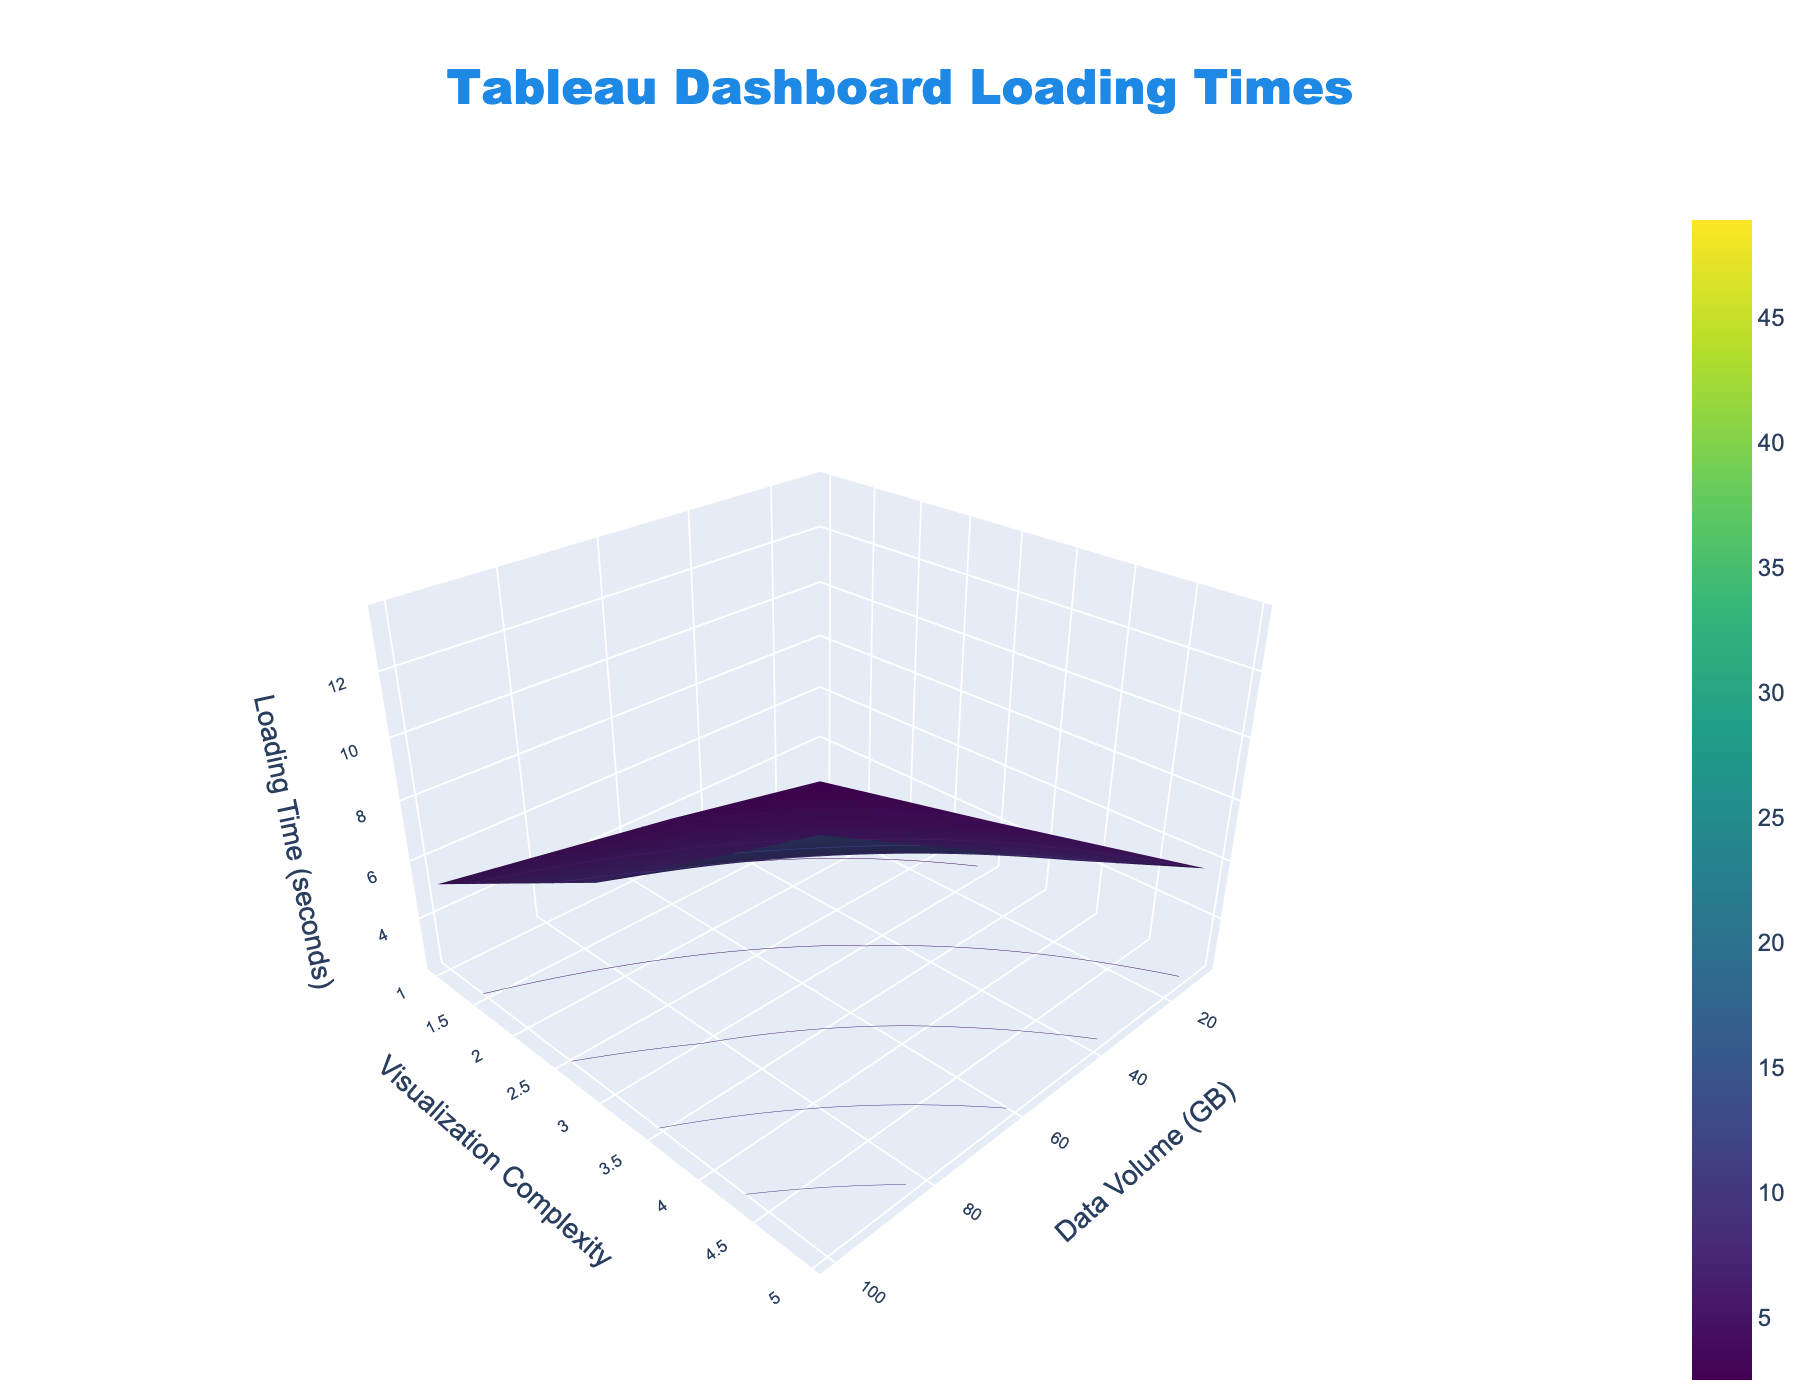What is the title of the 3D surface plot? The title of the plot is prominent at the top and reads "Tableau Dashboard Loading Times."
Answer: Tableau Dashboard Loading Times What are the labels for the x-axis, y-axis, and z-axis? The x-axis is labeled "Data Volume (GB)," the y-axis is labeled "Visualization Complexity," and the z-axis is labeled "Loading Time (seconds)," as indicated in the respective axis titles.
Answer: Data Volume (GB), Visualization Complexity, Loading Time (seconds) How does loading time change as the data volume increases from 10 GB to 1000 GB for a visualization complexity of 1? Observing the plot, as the data volume increases from 10 GB to 1000 GB, the loading time increases from 2.5 seconds to 18.7 seconds for a visualization complexity of 1.
Answer: Loading time increases from 2.5 to 18.7 seconds What is the effect of increasing visualization complexity from 1 to 5 on loading time when the data volume is 500 GB? When the data volume is 500 GB, increasing visualization complexity from 1 to 5 significantly raises the loading time from 12.3 seconds to 31.6 seconds, as shown by the surface plot.
Answer: Increases from 12.3 to 31.6 seconds Compare the loading times for data volumes of 50 GB and 250 GB at a visualization complexity of 3. At a visualization complexity of 3, the loading times are 6.3 seconds for 50 GB and 14.5 seconds for 250 GB, indicating a substantial increase in loading time with higher data volumes.
Answer: 6.3 seconds for 50 GB, 14.5 seconds for 250 GB Which data point on the plot shows the maximum loading time? The maximum loading time on the plot is 48.9 seconds, observed at the highest data volume (1000 GB) and highest visualization complexity (5).
Answer: 48.9 seconds at 1000 GB and complexity 5 How much longer does it take to load a dashboard with 250 GB data and complexity of 3 compared to a dashboard with 100 GB data and the same complexity? For complexity of 3, a dashboard with 250 GB data has a loading time of 14.5 seconds, whereas for 100 GB data, it is 9.2 seconds. The difference in loading time is 14.5 - 9.2 = 5.3 seconds.
Answer: 5.3 seconds Identify the trend in loading times as visualization complexity varies for a fixed data volume of 50 GB. For a fixed data volume of 50 GB, increasing the visualization complexity from 1 to 5 results in loading times increasing from 4.1 to 8.9 seconds, showing a positive correlation between complexity and loading time.
Answer: Loading time increases from 4.1 to 8.9 seconds What's the average loading time for visualizations with data volumes of 250 GB across all complexities? The loading times for 250 GB are 8.6 (complexity 1), 14.5 (complexity 3), and 21.3 seconds (complexity 5). Averaging these, (8.6 + 14.5 + 21.3) / 3 = 14.8 seconds.
Answer: 14.8 seconds 